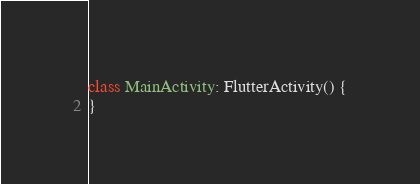<code> <loc_0><loc_0><loc_500><loc_500><_Kotlin_>class MainActivity: FlutterActivity() {
}
</code> 